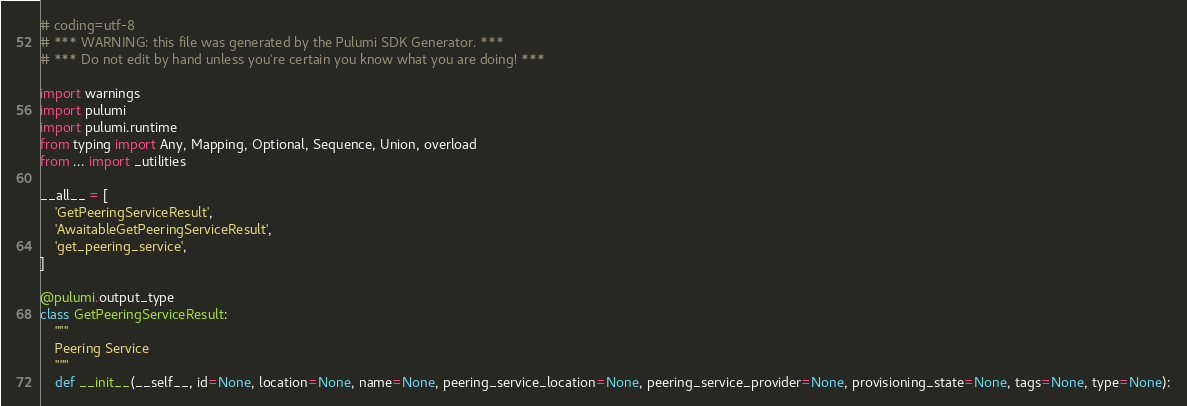Convert code to text. <code><loc_0><loc_0><loc_500><loc_500><_Python_># coding=utf-8
# *** WARNING: this file was generated by the Pulumi SDK Generator. ***
# *** Do not edit by hand unless you're certain you know what you are doing! ***

import warnings
import pulumi
import pulumi.runtime
from typing import Any, Mapping, Optional, Sequence, Union, overload
from ... import _utilities

__all__ = [
    'GetPeeringServiceResult',
    'AwaitableGetPeeringServiceResult',
    'get_peering_service',
]

@pulumi.output_type
class GetPeeringServiceResult:
    """
    Peering Service
    """
    def __init__(__self__, id=None, location=None, name=None, peering_service_location=None, peering_service_provider=None, provisioning_state=None, tags=None, type=None):</code> 